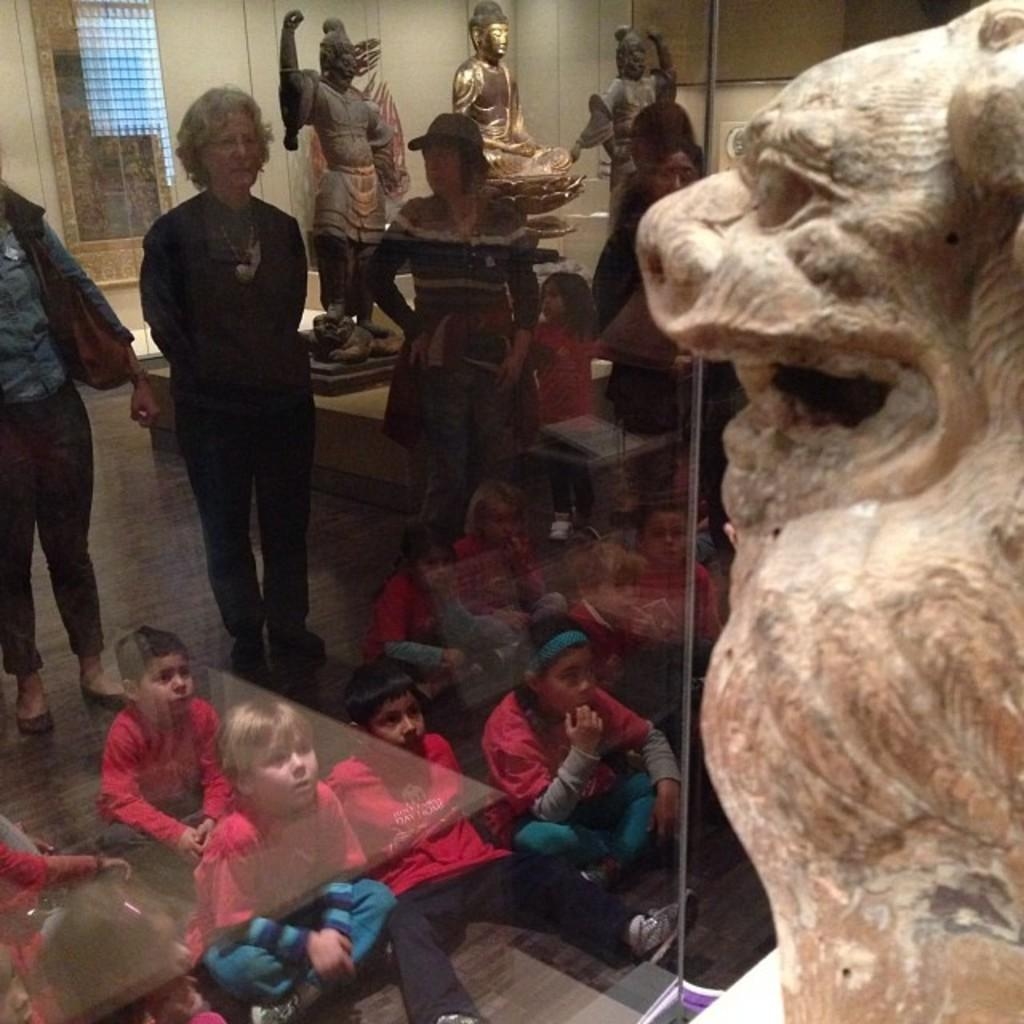What objects are present in the image? There are statues in the image. Are there any living beings in the image? Yes, there are people in the image. What is the color of the wall visible in the image? The wall in the image is white-colored. What type of pet can be seen playing with a board in the image? There is no pet or board present in the image. What kind of shop is visible in the image? There is no shop visible in the image. 